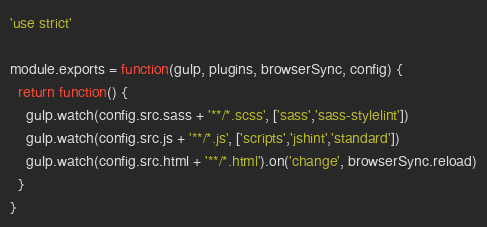Convert code to text. <code><loc_0><loc_0><loc_500><loc_500><_JavaScript_>'use strict'

module.exports = function(gulp, plugins, browserSync, config) {
  return function() {
    gulp.watch(config.src.sass + '**/*.scss', ['sass','sass-stylelint'])
    gulp.watch(config.src.js + '**/*.js', ['scripts','jshint','standard'])
    gulp.watch(config.src.html + '**/*.html').on('change', browserSync.reload)
  }
}
</code> 